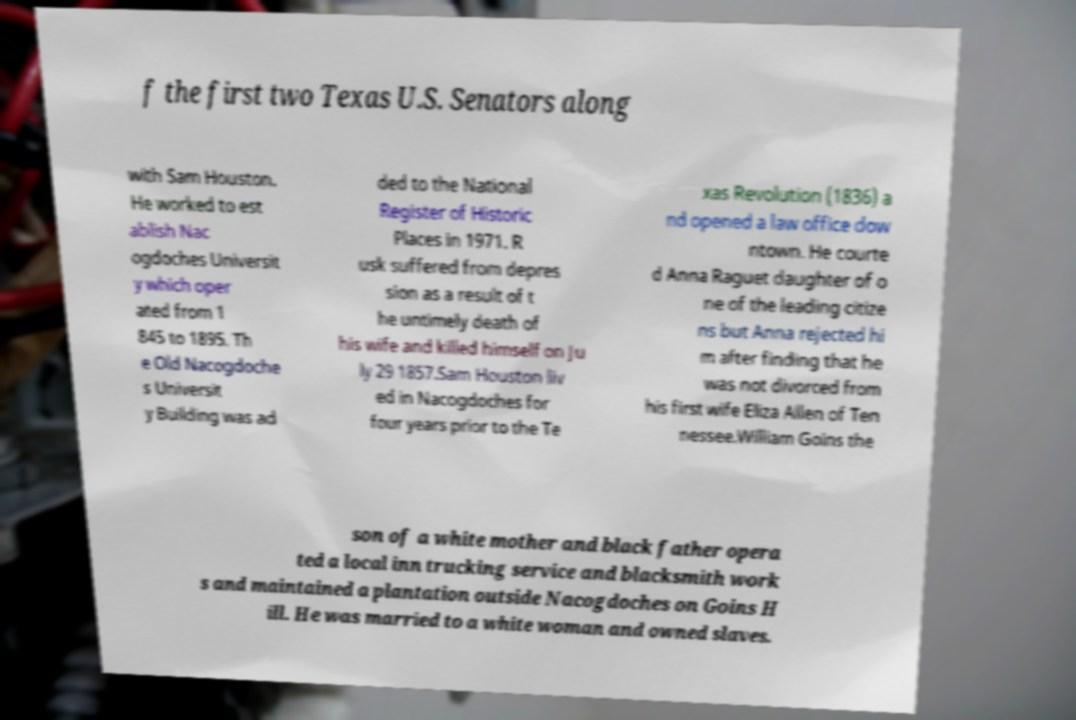Please read and relay the text visible in this image. What does it say? f the first two Texas U.S. Senators along with Sam Houston. He worked to est ablish Nac ogdoches Universit y which oper ated from 1 845 to 1895. Th e Old Nacogdoche s Universit y Building was ad ded to the National Register of Historic Places in 1971. R usk suffered from depres sion as a result of t he untimely death of his wife and killed himself on Ju ly 29 1857.Sam Houston liv ed in Nacogdoches for four years prior to the Te xas Revolution (1836) a nd opened a law office dow ntown. He courte d Anna Raguet daughter of o ne of the leading citize ns but Anna rejected hi m after finding that he was not divorced from his first wife Eliza Allen of Ten nessee.William Goins the son of a white mother and black father opera ted a local inn trucking service and blacksmith work s and maintained a plantation outside Nacogdoches on Goins H ill. He was married to a white woman and owned slaves. 